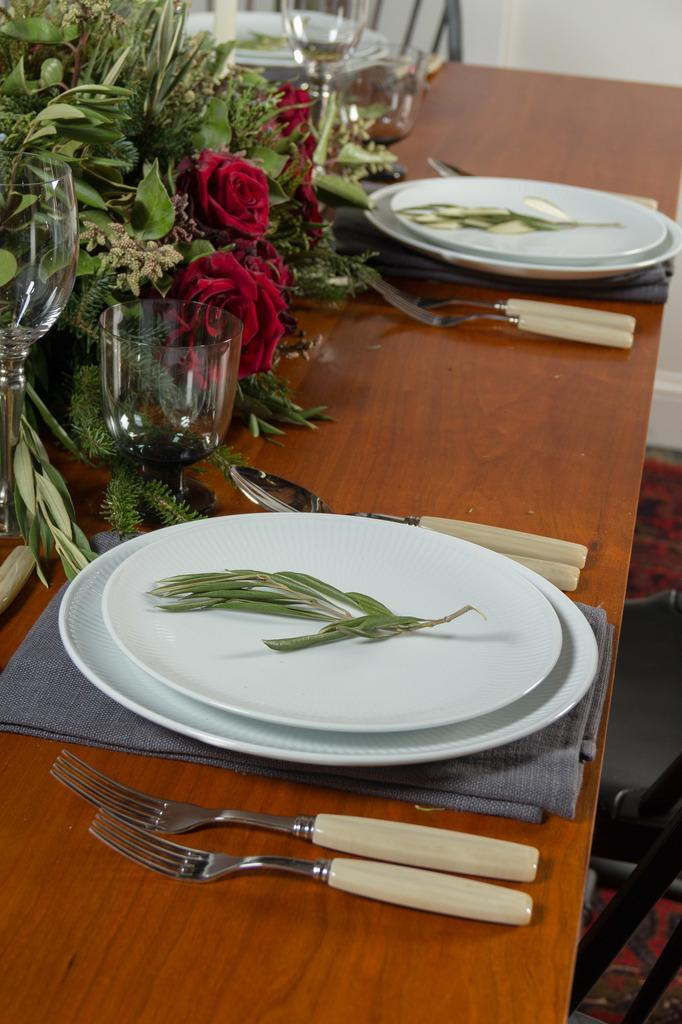What color is the wall in the image? The wall in the image is white. What piece of furniture is present in the image? There is a table in the image. What utensils can be seen on the table? There are forks, spoons, and plates on the table. What type of dishware is present on the table? There are plates on the table. What type of beverage container is on the table? There are glasses on the table. What decorative item is on the table? There is a bouquet on the table. What type of rhythm is being played by the hook in the image? There is no hook or rhythm present in the image. What type of wave can be seen in the image? There is no wave present in the image. 